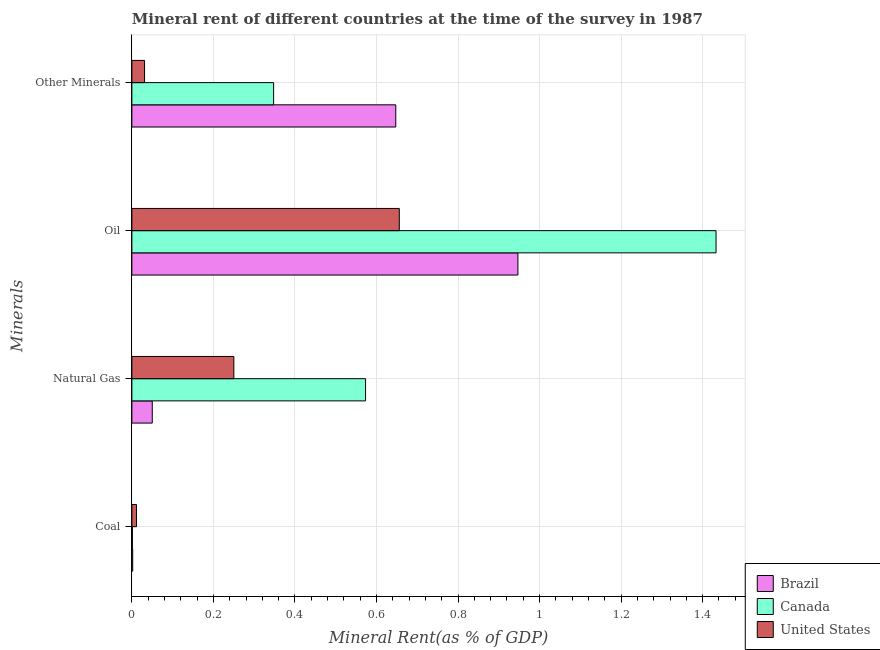How many different coloured bars are there?
Your response must be concise. 3. How many groups of bars are there?
Provide a succinct answer. 4. Are the number of bars per tick equal to the number of legend labels?
Keep it short and to the point. Yes. How many bars are there on the 4th tick from the bottom?
Provide a short and direct response. 3. What is the label of the 3rd group of bars from the top?
Offer a very short reply. Natural Gas. What is the coal rent in United States?
Keep it short and to the point. 0.01. Across all countries, what is the maximum  rent of other minerals?
Ensure brevity in your answer.  0.65. Across all countries, what is the minimum natural gas rent?
Provide a short and direct response. 0.05. In which country was the coal rent maximum?
Provide a succinct answer. United States. What is the total natural gas rent in the graph?
Your answer should be compact. 0.87. What is the difference between the coal rent in Canada and that in Brazil?
Make the answer very short. -0. What is the difference between the oil rent in Canada and the coal rent in Brazil?
Give a very brief answer. 1.43. What is the average coal rent per country?
Offer a very short reply. 0. What is the difference between the natural gas rent and coal rent in Canada?
Keep it short and to the point. 0.57. In how many countries, is the  rent of other minerals greater than 0.6000000000000001 %?
Provide a short and direct response. 1. What is the ratio of the oil rent in Canada to that in United States?
Keep it short and to the point. 2.18. Is the natural gas rent in Canada less than that in Brazil?
Give a very brief answer. No. Is the difference between the natural gas rent in Canada and Brazil greater than the difference between the oil rent in Canada and Brazil?
Your response must be concise. Yes. What is the difference between the highest and the second highest coal rent?
Make the answer very short. 0.01. What is the difference between the highest and the lowest natural gas rent?
Ensure brevity in your answer.  0.52. In how many countries, is the natural gas rent greater than the average natural gas rent taken over all countries?
Give a very brief answer. 1. Is it the case that in every country, the sum of the  rent of other minerals and oil rent is greater than the sum of natural gas rent and coal rent?
Your response must be concise. No. What does the 2nd bar from the top in Natural Gas represents?
Your answer should be compact. Canada. What does the 2nd bar from the bottom in Natural Gas represents?
Your response must be concise. Canada. How many bars are there?
Your answer should be very brief. 12. How are the legend labels stacked?
Your answer should be compact. Vertical. What is the title of the graph?
Your answer should be compact. Mineral rent of different countries at the time of the survey in 1987. Does "Arab World" appear as one of the legend labels in the graph?
Keep it short and to the point. No. What is the label or title of the X-axis?
Give a very brief answer. Mineral Rent(as % of GDP). What is the label or title of the Y-axis?
Provide a short and direct response. Minerals. What is the Mineral Rent(as % of GDP) of Brazil in Coal?
Keep it short and to the point. 0. What is the Mineral Rent(as % of GDP) in Canada in Coal?
Your response must be concise. 0. What is the Mineral Rent(as % of GDP) in United States in Coal?
Make the answer very short. 0.01. What is the Mineral Rent(as % of GDP) in Brazil in Natural Gas?
Keep it short and to the point. 0.05. What is the Mineral Rent(as % of GDP) of Canada in Natural Gas?
Ensure brevity in your answer.  0.57. What is the Mineral Rent(as % of GDP) in United States in Natural Gas?
Provide a succinct answer. 0.25. What is the Mineral Rent(as % of GDP) of Brazil in Oil?
Your answer should be compact. 0.95. What is the Mineral Rent(as % of GDP) of Canada in Oil?
Ensure brevity in your answer.  1.43. What is the Mineral Rent(as % of GDP) of United States in Oil?
Offer a very short reply. 0.66. What is the Mineral Rent(as % of GDP) of Brazil in Other Minerals?
Your answer should be compact. 0.65. What is the Mineral Rent(as % of GDP) of Canada in Other Minerals?
Your answer should be compact. 0.35. What is the Mineral Rent(as % of GDP) in United States in Other Minerals?
Your response must be concise. 0.03. Across all Minerals, what is the maximum Mineral Rent(as % of GDP) of Brazil?
Provide a short and direct response. 0.95. Across all Minerals, what is the maximum Mineral Rent(as % of GDP) in Canada?
Give a very brief answer. 1.43. Across all Minerals, what is the maximum Mineral Rent(as % of GDP) of United States?
Your answer should be very brief. 0.66. Across all Minerals, what is the minimum Mineral Rent(as % of GDP) of Brazil?
Your answer should be compact. 0. Across all Minerals, what is the minimum Mineral Rent(as % of GDP) of Canada?
Offer a terse response. 0. Across all Minerals, what is the minimum Mineral Rent(as % of GDP) in United States?
Make the answer very short. 0.01. What is the total Mineral Rent(as % of GDP) of Brazil in the graph?
Give a very brief answer. 1.65. What is the total Mineral Rent(as % of GDP) of Canada in the graph?
Your answer should be very brief. 2.36. What is the total Mineral Rent(as % of GDP) in United States in the graph?
Your response must be concise. 0.95. What is the difference between the Mineral Rent(as % of GDP) in Brazil in Coal and that in Natural Gas?
Keep it short and to the point. -0.05. What is the difference between the Mineral Rent(as % of GDP) in Canada in Coal and that in Natural Gas?
Offer a terse response. -0.57. What is the difference between the Mineral Rent(as % of GDP) of United States in Coal and that in Natural Gas?
Your answer should be very brief. -0.24. What is the difference between the Mineral Rent(as % of GDP) of Brazil in Coal and that in Oil?
Your response must be concise. -0.94. What is the difference between the Mineral Rent(as % of GDP) in Canada in Coal and that in Oil?
Make the answer very short. -1.43. What is the difference between the Mineral Rent(as % of GDP) of United States in Coal and that in Oil?
Provide a short and direct response. -0.64. What is the difference between the Mineral Rent(as % of GDP) of Brazil in Coal and that in Other Minerals?
Give a very brief answer. -0.65. What is the difference between the Mineral Rent(as % of GDP) in Canada in Coal and that in Other Minerals?
Ensure brevity in your answer.  -0.35. What is the difference between the Mineral Rent(as % of GDP) of United States in Coal and that in Other Minerals?
Give a very brief answer. -0.02. What is the difference between the Mineral Rent(as % of GDP) of Brazil in Natural Gas and that in Oil?
Offer a very short reply. -0.9. What is the difference between the Mineral Rent(as % of GDP) of Canada in Natural Gas and that in Oil?
Your response must be concise. -0.86. What is the difference between the Mineral Rent(as % of GDP) of United States in Natural Gas and that in Oil?
Your answer should be very brief. -0.41. What is the difference between the Mineral Rent(as % of GDP) of Brazil in Natural Gas and that in Other Minerals?
Your response must be concise. -0.6. What is the difference between the Mineral Rent(as % of GDP) of Canada in Natural Gas and that in Other Minerals?
Make the answer very short. 0.23. What is the difference between the Mineral Rent(as % of GDP) in United States in Natural Gas and that in Other Minerals?
Provide a short and direct response. 0.22. What is the difference between the Mineral Rent(as % of GDP) in Brazil in Oil and that in Other Minerals?
Provide a short and direct response. 0.3. What is the difference between the Mineral Rent(as % of GDP) of Canada in Oil and that in Other Minerals?
Give a very brief answer. 1.09. What is the difference between the Mineral Rent(as % of GDP) in United States in Oil and that in Other Minerals?
Your answer should be compact. 0.62. What is the difference between the Mineral Rent(as % of GDP) of Brazil in Coal and the Mineral Rent(as % of GDP) of Canada in Natural Gas?
Offer a terse response. -0.57. What is the difference between the Mineral Rent(as % of GDP) of Brazil in Coal and the Mineral Rent(as % of GDP) of United States in Natural Gas?
Make the answer very short. -0.25. What is the difference between the Mineral Rent(as % of GDP) of Canada in Coal and the Mineral Rent(as % of GDP) of United States in Natural Gas?
Offer a terse response. -0.25. What is the difference between the Mineral Rent(as % of GDP) of Brazil in Coal and the Mineral Rent(as % of GDP) of Canada in Oil?
Your answer should be compact. -1.43. What is the difference between the Mineral Rent(as % of GDP) in Brazil in Coal and the Mineral Rent(as % of GDP) in United States in Oil?
Offer a terse response. -0.65. What is the difference between the Mineral Rent(as % of GDP) of Canada in Coal and the Mineral Rent(as % of GDP) of United States in Oil?
Provide a succinct answer. -0.65. What is the difference between the Mineral Rent(as % of GDP) of Brazil in Coal and the Mineral Rent(as % of GDP) of Canada in Other Minerals?
Offer a very short reply. -0.35. What is the difference between the Mineral Rent(as % of GDP) of Brazil in Coal and the Mineral Rent(as % of GDP) of United States in Other Minerals?
Give a very brief answer. -0.03. What is the difference between the Mineral Rent(as % of GDP) in Canada in Coal and the Mineral Rent(as % of GDP) in United States in Other Minerals?
Offer a terse response. -0.03. What is the difference between the Mineral Rent(as % of GDP) in Brazil in Natural Gas and the Mineral Rent(as % of GDP) in Canada in Oil?
Give a very brief answer. -1.38. What is the difference between the Mineral Rent(as % of GDP) of Brazil in Natural Gas and the Mineral Rent(as % of GDP) of United States in Oil?
Your answer should be compact. -0.61. What is the difference between the Mineral Rent(as % of GDP) in Canada in Natural Gas and the Mineral Rent(as % of GDP) in United States in Oil?
Your answer should be very brief. -0.08. What is the difference between the Mineral Rent(as % of GDP) in Brazil in Natural Gas and the Mineral Rent(as % of GDP) in Canada in Other Minerals?
Your answer should be compact. -0.3. What is the difference between the Mineral Rent(as % of GDP) in Brazil in Natural Gas and the Mineral Rent(as % of GDP) in United States in Other Minerals?
Ensure brevity in your answer.  0.02. What is the difference between the Mineral Rent(as % of GDP) in Canada in Natural Gas and the Mineral Rent(as % of GDP) in United States in Other Minerals?
Offer a terse response. 0.54. What is the difference between the Mineral Rent(as % of GDP) of Brazil in Oil and the Mineral Rent(as % of GDP) of Canada in Other Minerals?
Give a very brief answer. 0.6. What is the difference between the Mineral Rent(as % of GDP) in Brazil in Oil and the Mineral Rent(as % of GDP) in United States in Other Minerals?
Offer a terse response. 0.92. What is the difference between the Mineral Rent(as % of GDP) of Canada in Oil and the Mineral Rent(as % of GDP) of United States in Other Minerals?
Your response must be concise. 1.4. What is the average Mineral Rent(as % of GDP) in Brazil per Minerals?
Provide a succinct answer. 0.41. What is the average Mineral Rent(as % of GDP) of Canada per Minerals?
Provide a short and direct response. 0.59. What is the average Mineral Rent(as % of GDP) in United States per Minerals?
Offer a very short reply. 0.24. What is the difference between the Mineral Rent(as % of GDP) of Brazil and Mineral Rent(as % of GDP) of Canada in Coal?
Provide a succinct answer. 0. What is the difference between the Mineral Rent(as % of GDP) in Brazil and Mineral Rent(as % of GDP) in United States in Coal?
Your answer should be compact. -0.01. What is the difference between the Mineral Rent(as % of GDP) in Canada and Mineral Rent(as % of GDP) in United States in Coal?
Offer a terse response. -0.01. What is the difference between the Mineral Rent(as % of GDP) in Brazil and Mineral Rent(as % of GDP) in Canada in Natural Gas?
Provide a short and direct response. -0.52. What is the difference between the Mineral Rent(as % of GDP) in Brazil and Mineral Rent(as % of GDP) in United States in Natural Gas?
Provide a succinct answer. -0.2. What is the difference between the Mineral Rent(as % of GDP) in Canada and Mineral Rent(as % of GDP) in United States in Natural Gas?
Provide a short and direct response. 0.32. What is the difference between the Mineral Rent(as % of GDP) in Brazil and Mineral Rent(as % of GDP) in Canada in Oil?
Give a very brief answer. -0.49. What is the difference between the Mineral Rent(as % of GDP) of Brazil and Mineral Rent(as % of GDP) of United States in Oil?
Offer a very short reply. 0.29. What is the difference between the Mineral Rent(as % of GDP) in Canada and Mineral Rent(as % of GDP) in United States in Oil?
Offer a terse response. 0.78. What is the difference between the Mineral Rent(as % of GDP) in Brazil and Mineral Rent(as % of GDP) in Canada in Other Minerals?
Your response must be concise. 0.3. What is the difference between the Mineral Rent(as % of GDP) of Brazil and Mineral Rent(as % of GDP) of United States in Other Minerals?
Your response must be concise. 0.62. What is the difference between the Mineral Rent(as % of GDP) in Canada and Mineral Rent(as % of GDP) in United States in Other Minerals?
Provide a succinct answer. 0.32. What is the ratio of the Mineral Rent(as % of GDP) of Brazil in Coal to that in Natural Gas?
Provide a succinct answer. 0.04. What is the ratio of the Mineral Rent(as % of GDP) in Canada in Coal to that in Natural Gas?
Offer a terse response. 0. What is the ratio of the Mineral Rent(as % of GDP) in United States in Coal to that in Natural Gas?
Offer a very short reply. 0.05. What is the ratio of the Mineral Rent(as % of GDP) of Brazil in Coal to that in Oil?
Offer a very short reply. 0. What is the ratio of the Mineral Rent(as % of GDP) in Canada in Coal to that in Oil?
Your answer should be compact. 0. What is the ratio of the Mineral Rent(as % of GDP) of United States in Coal to that in Oil?
Ensure brevity in your answer.  0.02. What is the ratio of the Mineral Rent(as % of GDP) in Brazil in Coal to that in Other Minerals?
Make the answer very short. 0. What is the ratio of the Mineral Rent(as % of GDP) in Canada in Coal to that in Other Minerals?
Your answer should be compact. 0. What is the ratio of the Mineral Rent(as % of GDP) in United States in Coal to that in Other Minerals?
Your answer should be compact. 0.36. What is the ratio of the Mineral Rent(as % of GDP) of Brazil in Natural Gas to that in Oil?
Give a very brief answer. 0.05. What is the ratio of the Mineral Rent(as % of GDP) of United States in Natural Gas to that in Oil?
Provide a short and direct response. 0.38. What is the ratio of the Mineral Rent(as % of GDP) of Brazil in Natural Gas to that in Other Minerals?
Give a very brief answer. 0.08. What is the ratio of the Mineral Rent(as % of GDP) in Canada in Natural Gas to that in Other Minerals?
Provide a succinct answer. 1.65. What is the ratio of the Mineral Rent(as % of GDP) of United States in Natural Gas to that in Other Minerals?
Keep it short and to the point. 8.05. What is the ratio of the Mineral Rent(as % of GDP) of Brazil in Oil to that in Other Minerals?
Your answer should be very brief. 1.46. What is the ratio of the Mineral Rent(as % of GDP) in Canada in Oil to that in Other Minerals?
Give a very brief answer. 4.12. What is the ratio of the Mineral Rent(as % of GDP) in United States in Oil to that in Other Minerals?
Offer a terse response. 21.1. What is the difference between the highest and the second highest Mineral Rent(as % of GDP) in Brazil?
Your answer should be very brief. 0.3. What is the difference between the highest and the second highest Mineral Rent(as % of GDP) in Canada?
Provide a succinct answer. 0.86. What is the difference between the highest and the second highest Mineral Rent(as % of GDP) of United States?
Offer a terse response. 0.41. What is the difference between the highest and the lowest Mineral Rent(as % of GDP) of Brazil?
Give a very brief answer. 0.94. What is the difference between the highest and the lowest Mineral Rent(as % of GDP) in Canada?
Your response must be concise. 1.43. What is the difference between the highest and the lowest Mineral Rent(as % of GDP) of United States?
Your answer should be very brief. 0.64. 